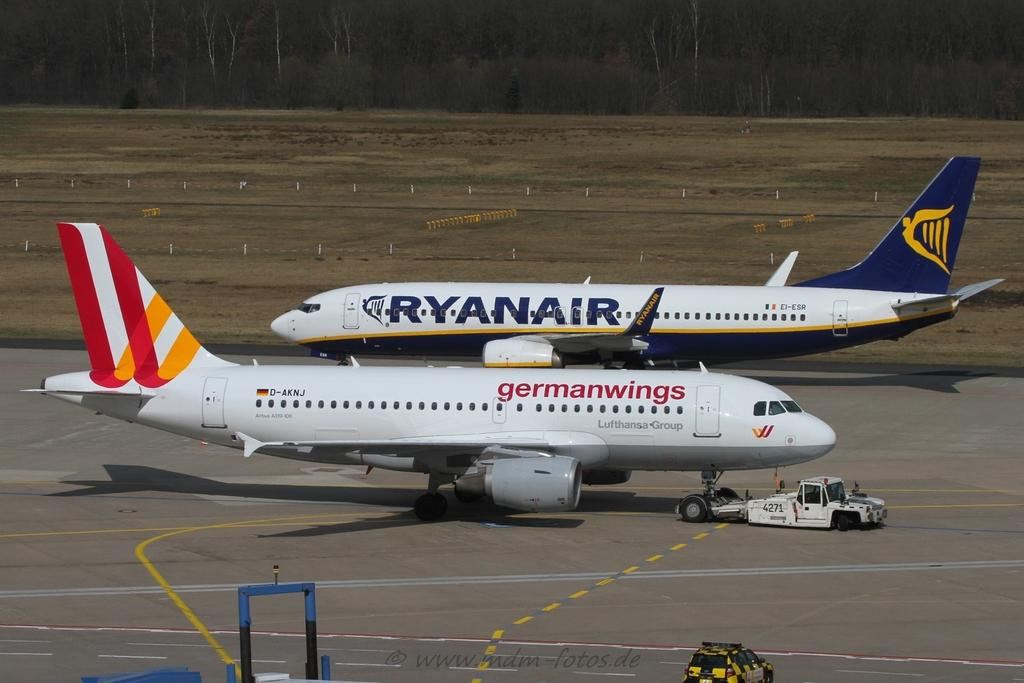<image>
Provide a brief description of the given image. One Ryanair and one Germanwings plane pass each other on the tarmac. 